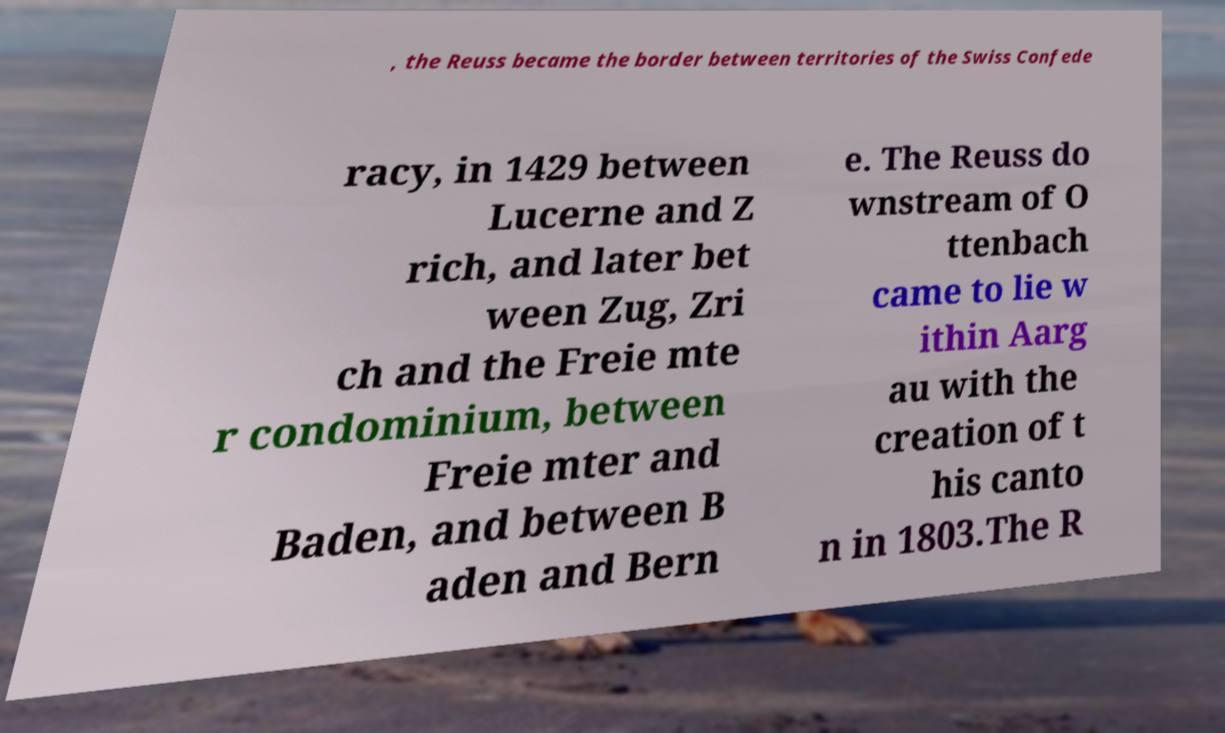Please identify and transcribe the text found in this image. , the Reuss became the border between territories of the Swiss Confede racy, in 1429 between Lucerne and Z rich, and later bet ween Zug, Zri ch and the Freie mte r condominium, between Freie mter and Baden, and between B aden and Bern e. The Reuss do wnstream of O ttenbach came to lie w ithin Aarg au with the creation of t his canto n in 1803.The R 